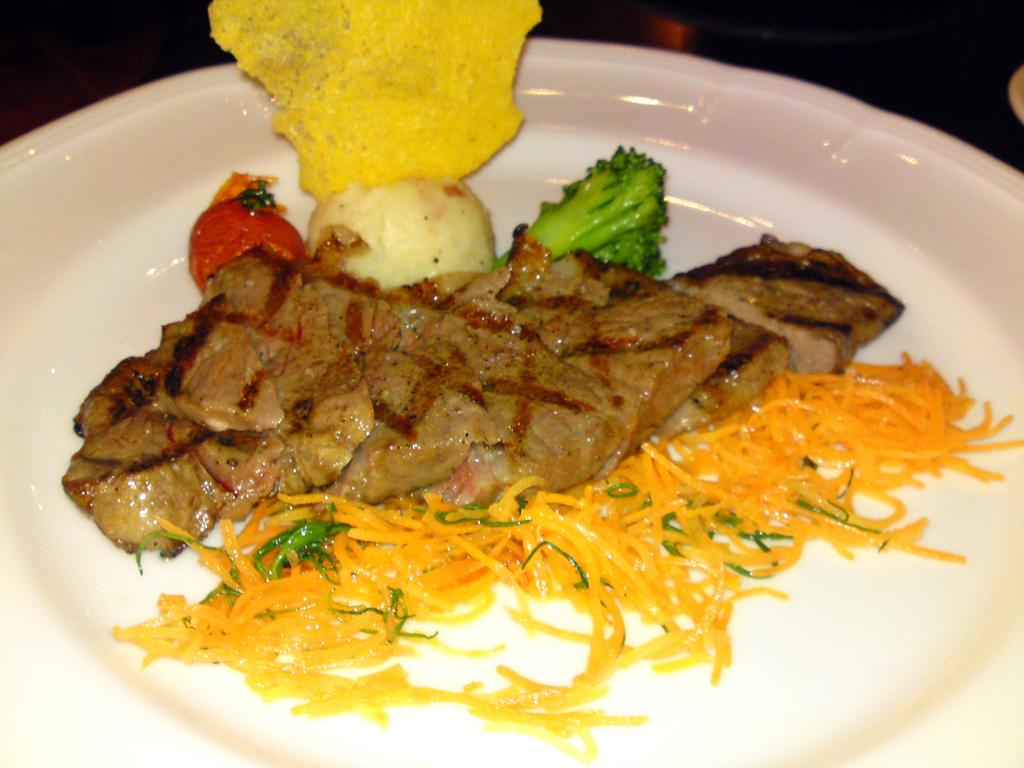What type of objects can be seen in the image? There are food items in the image. How are the food items arranged or presented? The food items are in a white color plate. What type of authority figure can be seen in the image? There is no authority figure present in the image; it only features food items on a white color plate. 